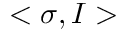Convert formula to latex. <formula><loc_0><loc_0><loc_500><loc_500>< \sigma , I ></formula> 